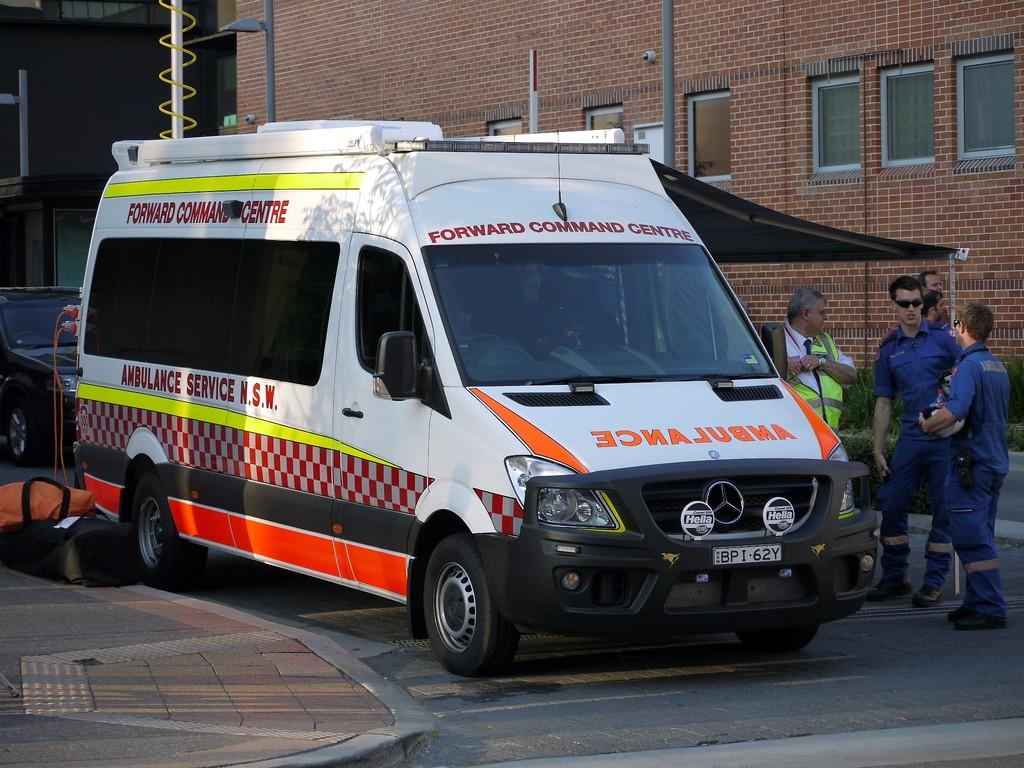What vehicle can be seen on the road in the image? There is an ambulance on the road in the image. What can be seen in the background behind the ambulance? There is a group of people standing, buildings, poles, bags, and a car in the background. Can you describe the buildings in the background? The buildings in the background are not described in detail, but they are present. What type of objects are the bags in the background? The type of bags is not specified in the image. What time of day is it in the image, based on the presence of a bird? There is no bird present in the image, so it is not possible to determine the time of day based on that information. 